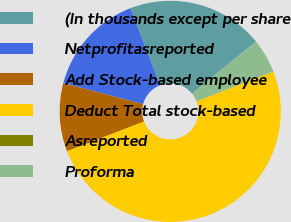Convert chart. <chart><loc_0><loc_0><loc_500><loc_500><pie_chart><fcel>(In thousands except per share<fcel>Netprofitasreported<fcel>Add Stock-based employee<fcel>Deduct Total stock-based<fcel>Asreported<fcel>Proforma<nl><fcel>20.0%<fcel>15.0%<fcel>10.0%<fcel>50.0%<fcel>0.0%<fcel>5.0%<nl></chart> 